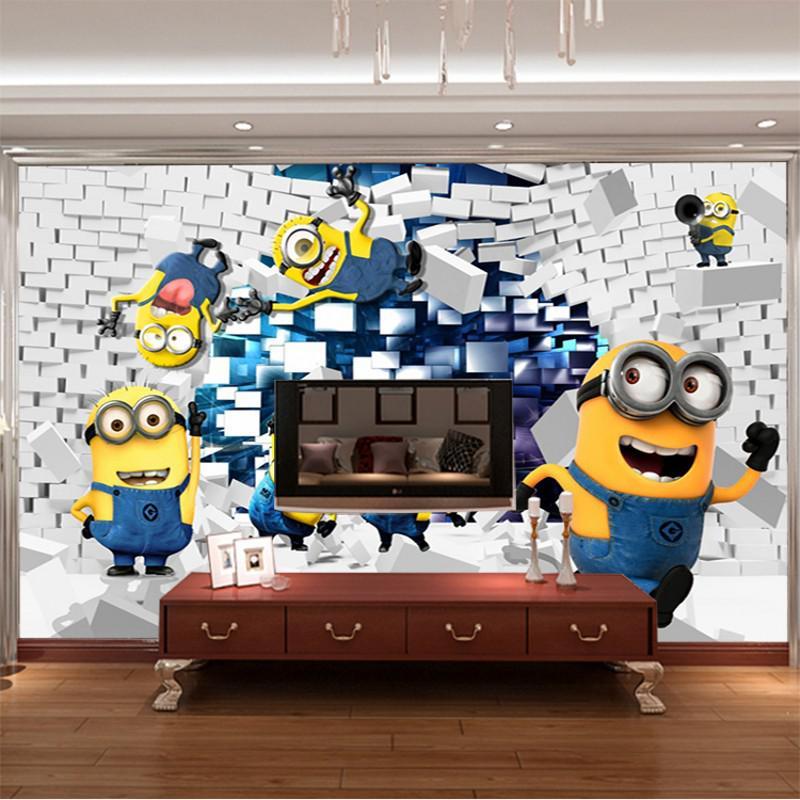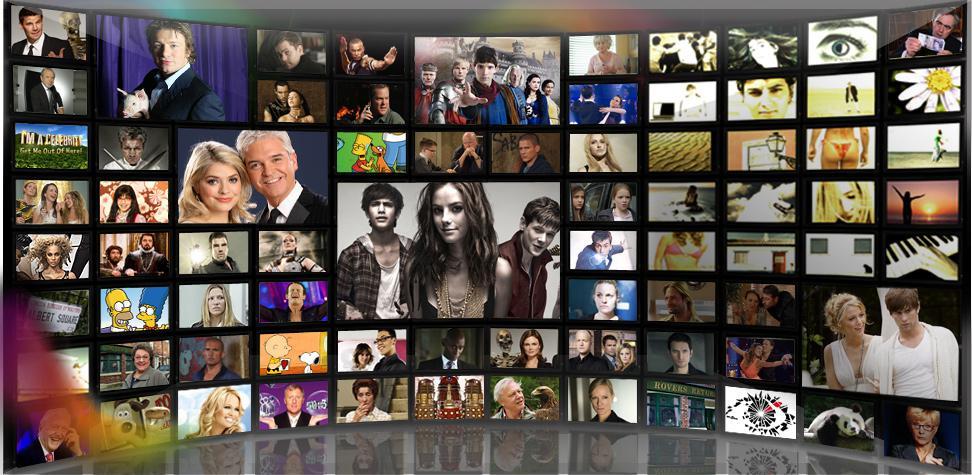The first image is the image on the left, the second image is the image on the right. For the images displayed, is the sentence "An image shows at least one customer in a bar equipped with a suspended TV screen." factually correct? Answer yes or no. No. The first image is the image on the left, the second image is the image on the right. Evaluate the accuracy of this statement regarding the images: "In one image, the restaurant with overhead television screens has seating on tall stools at tables with wooden tops.". Is it true? Answer yes or no. No. 